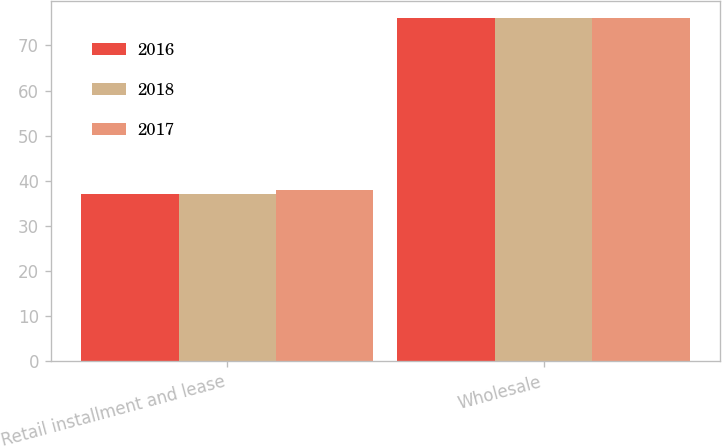Convert chart to OTSL. <chart><loc_0><loc_0><loc_500><loc_500><stacked_bar_chart><ecel><fcel>Retail installment and lease<fcel>Wholesale<nl><fcel>2016<fcel>37<fcel>76<nl><fcel>2018<fcel>37<fcel>76<nl><fcel>2017<fcel>38<fcel>76<nl></chart> 